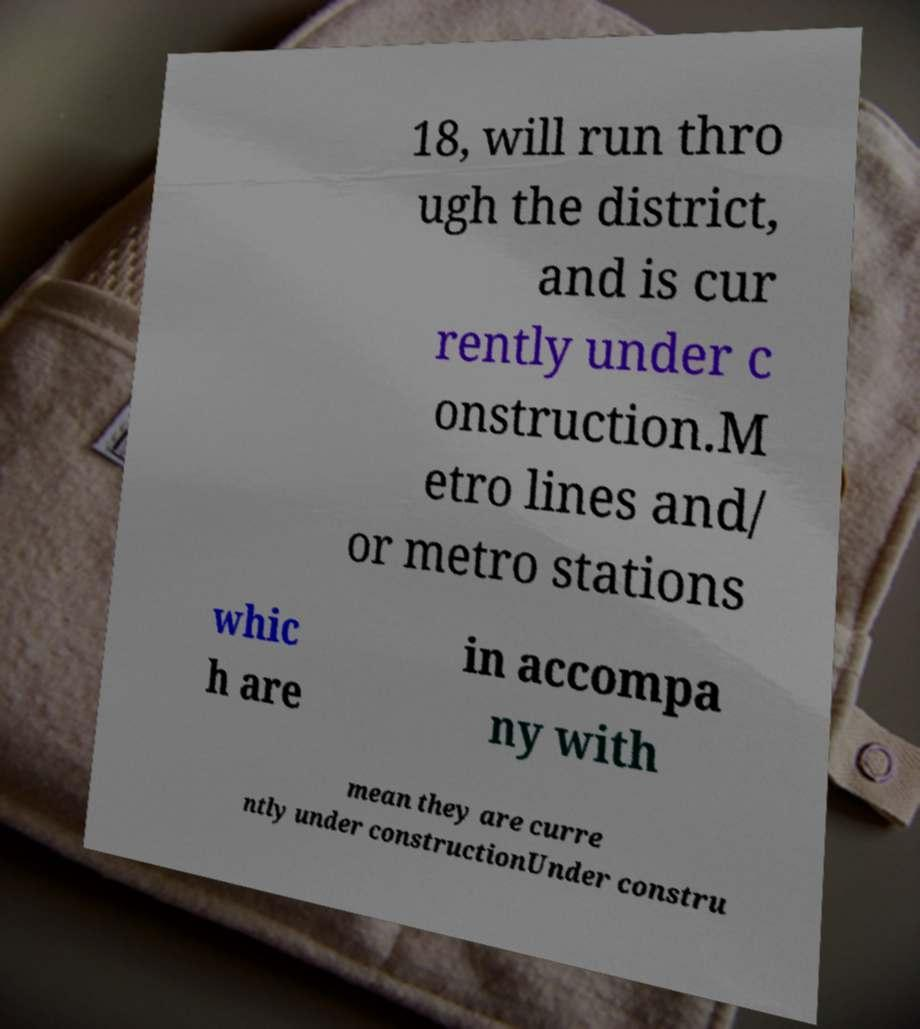There's text embedded in this image that I need extracted. Can you transcribe it verbatim? 18, will run thro ugh the district, and is cur rently under c onstruction.M etro lines and/ or metro stations whic h are in accompa ny with mean they are curre ntly under constructionUnder constru 